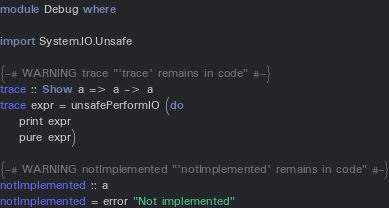Convert code to text. <code><loc_0><loc_0><loc_500><loc_500><_Haskell_>module Debug where

import System.IO.Unsafe

{-# WARNING trace "'trace' remains in code" #-}
trace :: Show a => a -> a
trace expr = unsafePerformIO (do
    print expr
    pure expr)

{-# WARNING notImplemented "'notImplemented' remains in code" #-}
notImplemented :: a
notImplemented = error "Not implemented"</code> 